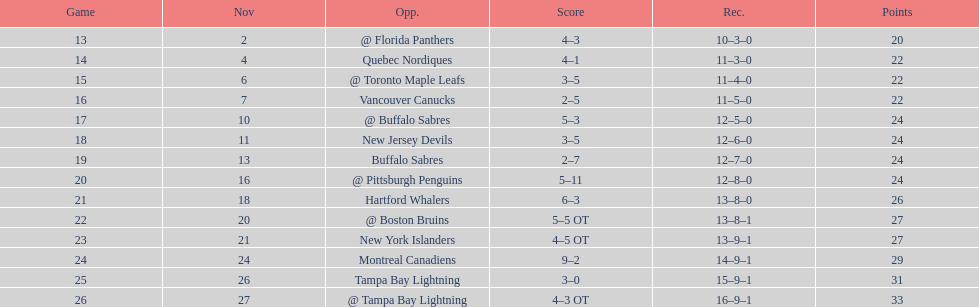Who had the most assists on the 1993-1994 flyers? Mark Recchi. 